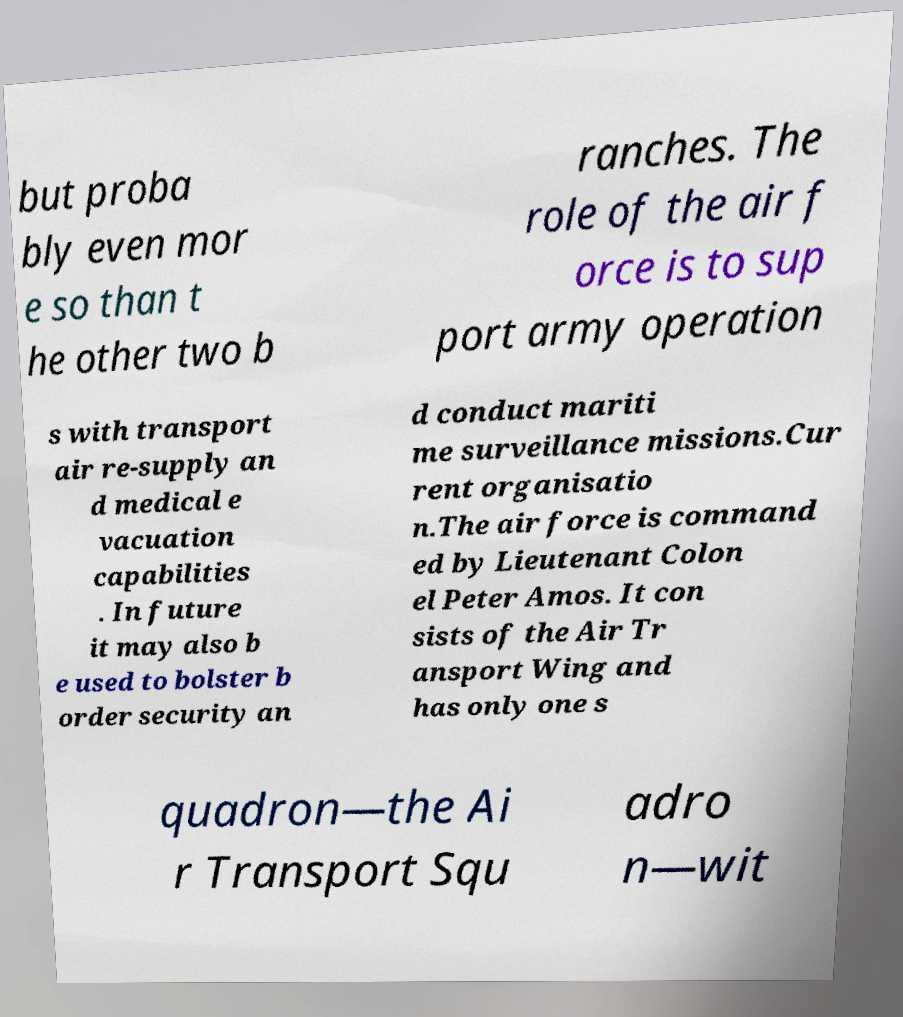Could you extract and type out the text from this image? but proba bly even mor e so than t he other two b ranches. The role of the air f orce is to sup port army operation s with transport air re-supply an d medical e vacuation capabilities . In future it may also b e used to bolster b order security an d conduct mariti me surveillance missions.Cur rent organisatio n.The air force is command ed by Lieutenant Colon el Peter Amos. It con sists of the Air Tr ansport Wing and has only one s quadron—the Ai r Transport Squ adro n—wit 